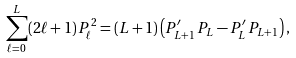<formula> <loc_0><loc_0><loc_500><loc_500>\sum _ { \ell = 0 } ^ { L } ( 2 \ell + 1 ) \, P _ { \ell } ^ { 2 } = ( L + 1 ) \left ( P ^ { \prime } _ { L + 1 } \, P _ { L } - P ^ { \prime } _ { L } \, P _ { L + 1 } \right ) ,</formula> 